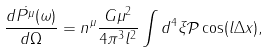<formula> <loc_0><loc_0><loc_500><loc_500>\frac { d \dot { P ^ { \mu } } ( { \omega } ) } { d \Omega } = n ^ { \mu } \frac { G \mu ^ { 2 } } { 4 \pi ^ { 3 } l ^ { 2 } } \int d ^ { 4 } \xi \mathcal { P } \cos ( l \Delta x ) ,</formula> 